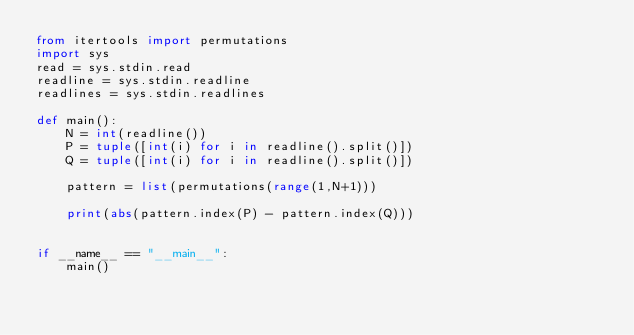Convert code to text. <code><loc_0><loc_0><loc_500><loc_500><_Python_>from itertools import permutations
import sys
read = sys.stdin.read
readline = sys.stdin.readline
readlines = sys.stdin.readlines

def main():
    N = int(readline())
    P = tuple([int(i) for i in readline().split()])
    Q = tuple([int(i) for i in readline().split()])

    pattern = list(permutations(range(1,N+1)))

    print(abs(pattern.index(P) - pattern.index(Q)))


if __name__ == "__main__":
    main()
</code> 